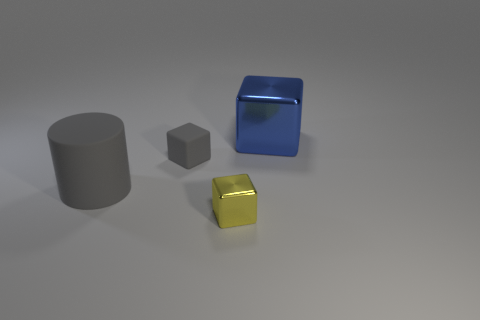Subtract all large blue shiny cubes. How many cubes are left? 2 Subtract all cylinders. How many objects are left? 3 Add 4 matte things. How many objects exist? 8 Subtract all gray cubes. How many cubes are left? 2 Subtract 2 blocks. How many blocks are left? 1 Subtract all gray cylinders. How many green cubes are left? 0 Subtract all metal things. Subtract all big gray things. How many objects are left? 1 Add 4 tiny objects. How many tiny objects are left? 6 Add 3 yellow shiny cubes. How many yellow shiny cubes exist? 4 Subtract 0 purple cubes. How many objects are left? 4 